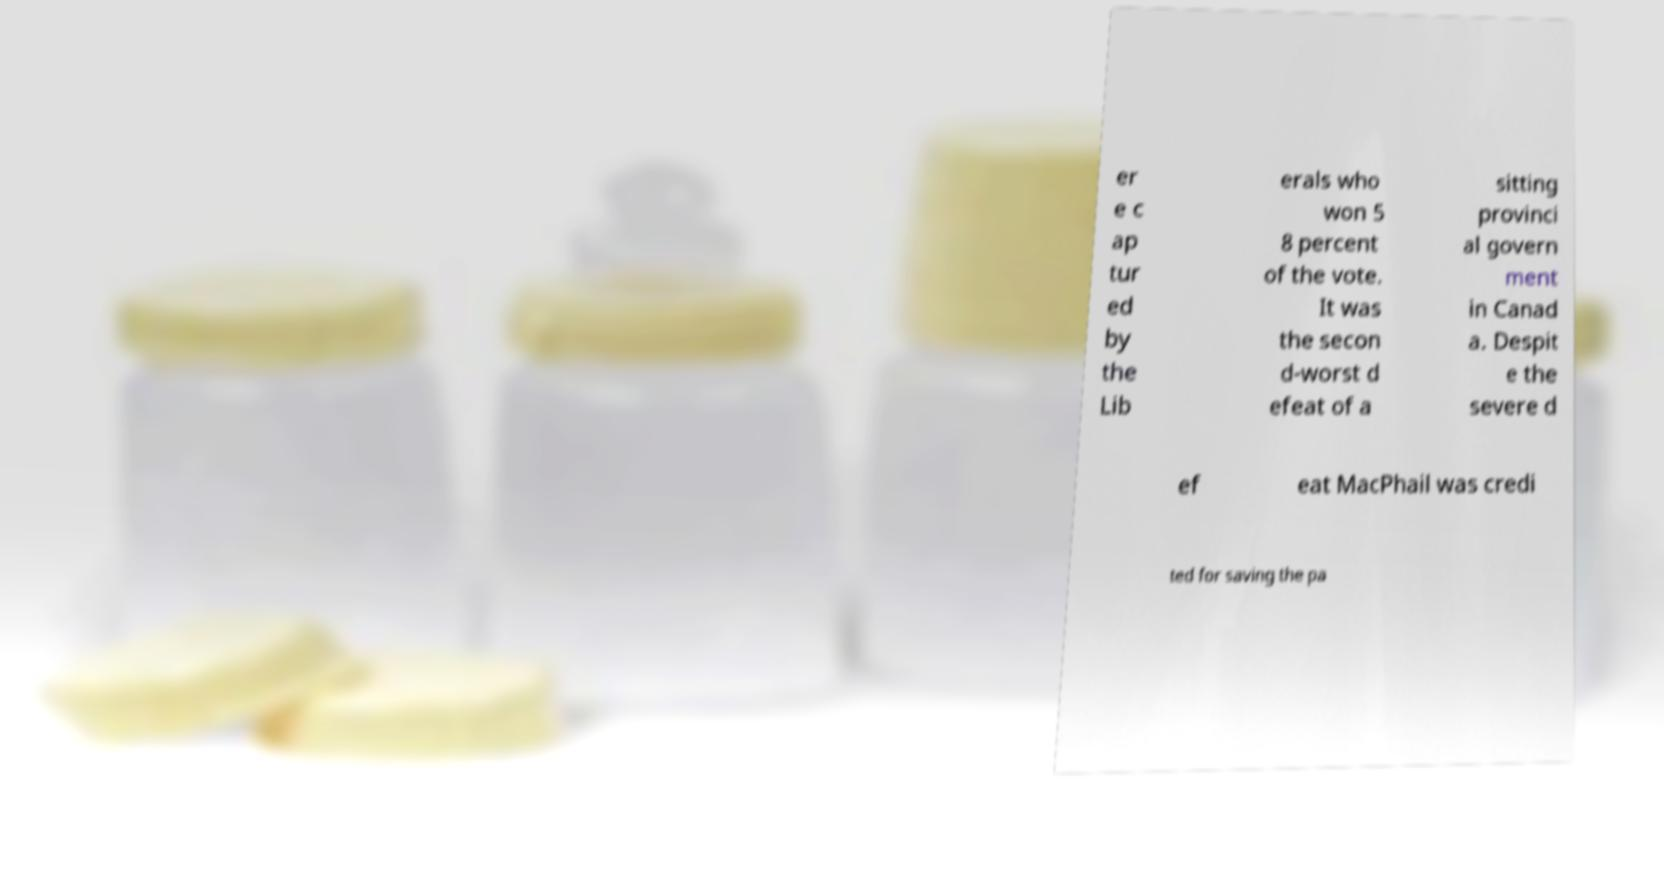What messages or text are displayed in this image? I need them in a readable, typed format. er e c ap tur ed by the Lib erals who won 5 8 percent of the vote. It was the secon d-worst d efeat of a sitting provinci al govern ment in Canad a. Despit e the severe d ef eat MacPhail was credi ted for saving the pa 